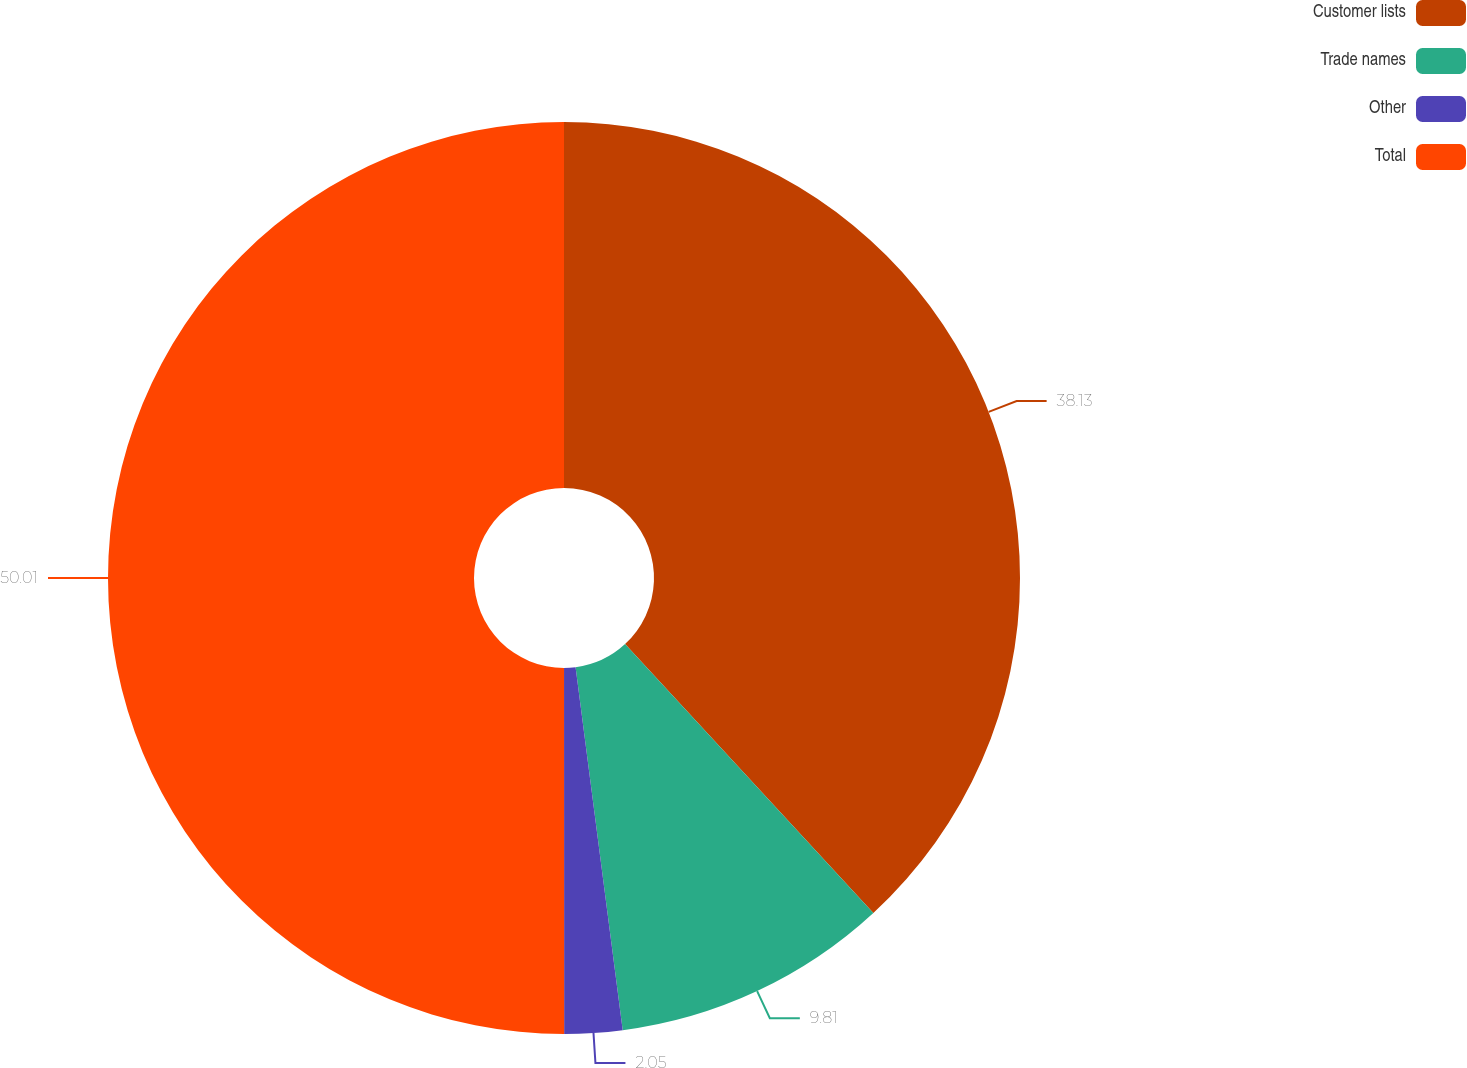Convert chart to OTSL. <chart><loc_0><loc_0><loc_500><loc_500><pie_chart><fcel>Customer lists<fcel>Trade names<fcel>Other<fcel>Total<nl><fcel>38.13%<fcel>9.81%<fcel>2.05%<fcel>50.0%<nl></chart> 